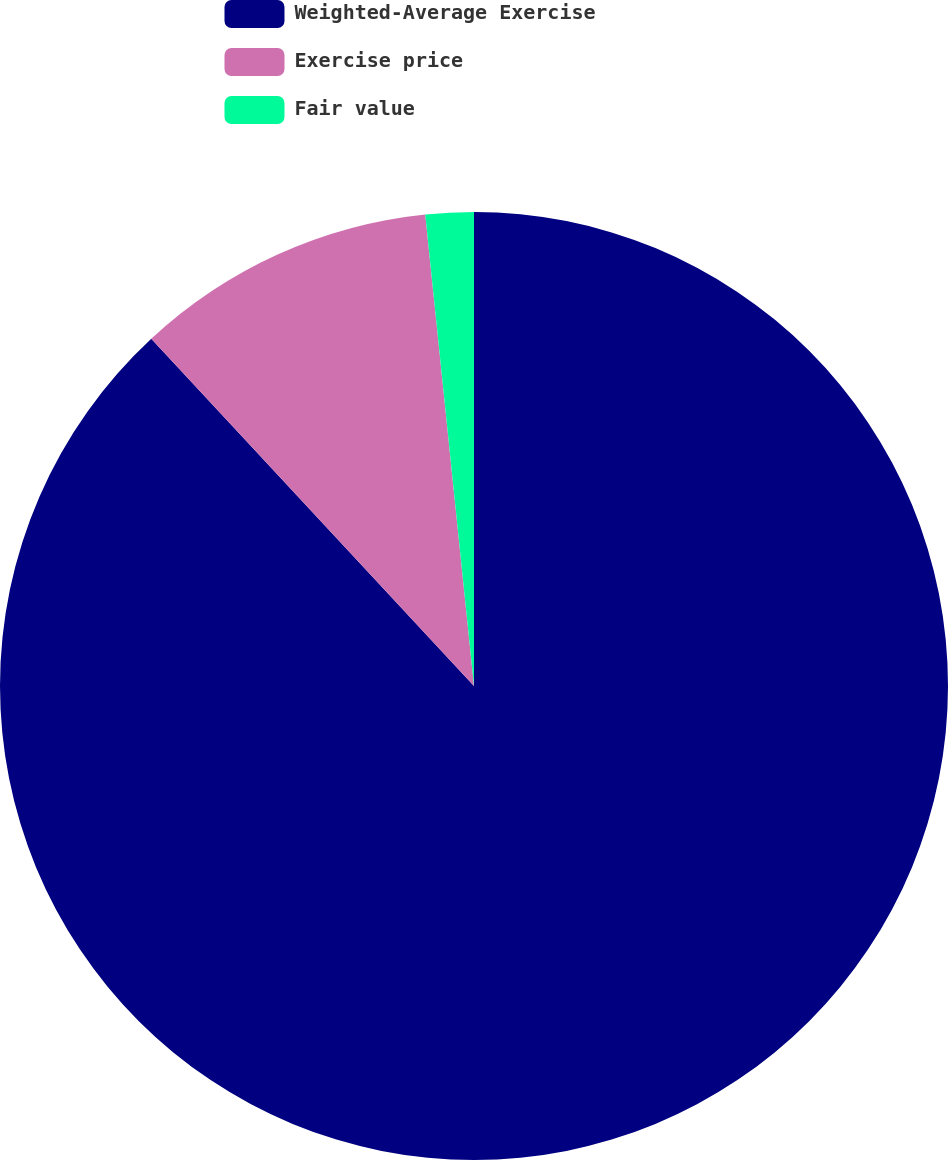Convert chart to OTSL. <chart><loc_0><loc_0><loc_500><loc_500><pie_chart><fcel>Weighted-Average Exercise<fcel>Exercise price<fcel>Fair value<nl><fcel>88.08%<fcel>10.28%<fcel>1.64%<nl></chart> 